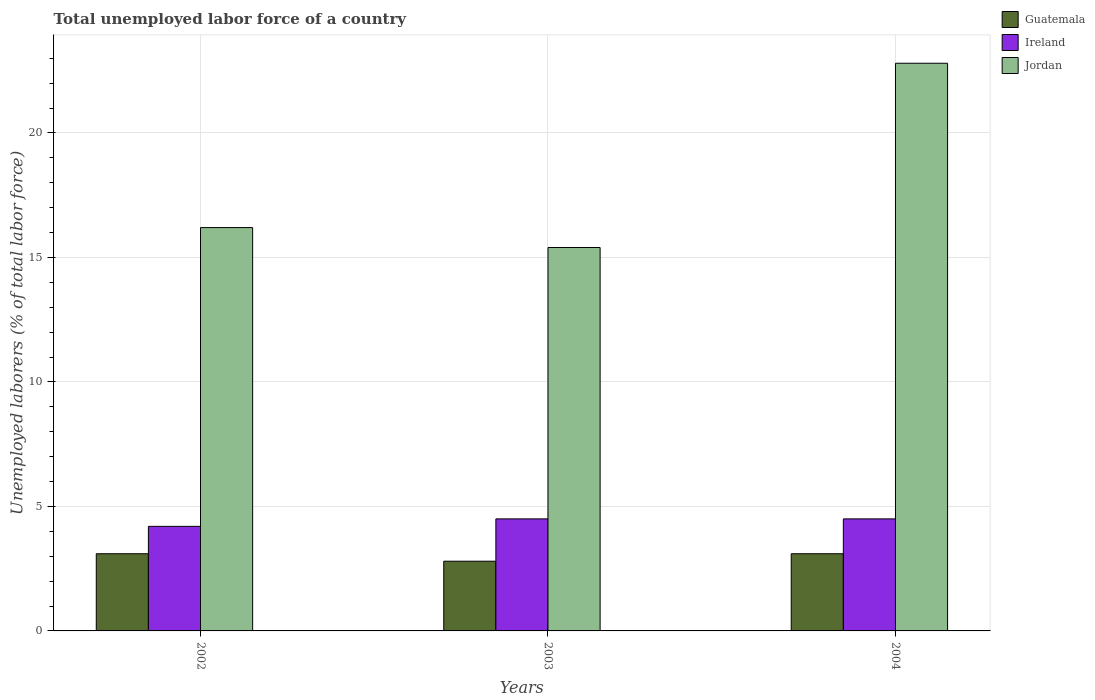How many groups of bars are there?
Your answer should be very brief. 3. Are the number of bars on each tick of the X-axis equal?
Provide a succinct answer. Yes. How many bars are there on the 1st tick from the right?
Keep it short and to the point. 3. What is the label of the 2nd group of bars from the left?
Provide a succinct answer. 2003. What is the total unemployed labor force in Jordan in 2003?
Provide a succinct answer. 15.4. Across all years, what is the minimum total unemployed labor force in Guatemala?
Offer a very short reply. 2.8. In which year was the total unemployed labor force in Guatemala minimum?
Your response must be concise. 2003. What is the total total unemployed labor force in Guatemala in the graph?
Ensure brevity in your answer.  9. What is the difference between the total unemployed labor force in Ireland in 2002 and that in 2003?
Offer a very short reply. -0.3. What is the difference between the total unemployed labor force in Ireland in 2003 and the total unemployed labor force in Guatemala in 2002?
Your answer should be very brief. 1.4. What is the average total unemployed labor force in Jordan per year?
Make the answer very short. 18.13. In the year 2002, what is the difference between the total unemployed labor force in Jordan and total unemployed labor force in Guatemala?
Your response must be concise. 13.1. In how many years, is the total unemployed labor force in Guatemala greater than 13 %?
Your answer should be very brief. 0. Is the total unemployed labor force in Guatemala in 2002 less than that in 2004?
Your answer should be very brief. No. What is the difference between the highest and the lowest total unemployed labor force in Ireland?
Ensure brevity in your answer.  0.3. In how many years, is the total unemployed labor force in Ireland greater than the average total unemployed labor force in Ireland taken over all years?
Provide a succinct answer. 2. What does the 1st bar from the left in 2002 represents?
Offer a very short reply. Guatemala. What does the 2nd bar from the right in 2003 represents?
Keep it short and to the point. Ireland. How many bars are there?
Offer a very short reply. 9. Are all the bars in the graph horizontal?
Provide a succinct answer. No. Does the graph contain any zero values?
Your response must be concise. No. Does the graph contain grids?
Your answer should be compact. Yes. Where does the legend appear in the graph?
Your response must be concise. Top right. What is the title of the graph?
Ensure brevity in your answer.  Total unemployed labor force of a country. What is the label or title of the X-axis?
Your answer should be very brief. Years. What is the label or title of the Y-axis?
Your response must be concise. Unemployed laborers (% of total labor force). What is the Unemployed laborers (% of total labor force) of Guatemala in 2002?
Make the answer very short. 3.1. What is the Unemployed laborers (% of total labor force) in Ireland in 2002?
Offer a terse response. 4.2. What is the Unemployed laborers (% of total labor force) in Jordan in 2002?
Provide a short and direct response. 16.2. What is the Unemployed laborers (% of total labor force) in Guatemala in 2003?
Your answer should be compact. 2.8. What is the Unemployed laborers (% of total labor force) in Ireland in 2003?
Provide a short and direct response. 4.5. What is the Unemployed laborers (% of total labor force) in Jordan in 2003?
Offer a terse response. 15.4. What is the Unemployed laborers (% of total labor force) in Guatemala in 2004?
Keep it short and to the point. 3.1. What is the Unemployed laborers (% of total labor force) of Ireland in 2004?
Your answer should be very brief. 4.5. What is the Unemployed laborers (% of total labor force) of Jordan in 2004?
Make the answer very short. 22.8. Across all years, what is the maximum Unemployed laborers (% of total labor force) of Guatemala?
Ensure brevity in your answer.  3.1. Across all years, what is the maximum Unemployed laborers (% of total labor force) in Jordan?
Offer a terse response. 22.8. Across all years, what is the minimum Unemployed laborers (% of total labor force) of Guatemala?
Your response must be concise. 2.8. Across all years, what is the minimum Unemployed laborers (% of total labor force) in Ireland?
Your answer should be very brief. 4.2. Across all years, what is the minimum Unemployed laborers (% of total labor force) of Jordan?
Provide a succinct answer. 15.4. What is the total Unemployed laborers (% of total labor force) of Ireland in the graph?
Offer a terse response. 13.2. What is the total Unemployed laborers (% of total labor force) of Jordan in the graph?
Keep it short and to the point. 54.4. What is the difference between the Unemployed laborers (% of total labor force) in Guatemala in 2002 and that in 2003?
Your answer should be very brief. 0.3. What is the difference between the Unemployed laborers (% of total labor force) of Jordan in 2002 and that in 2003?
Offer a terse response. 0.8. What is the difference between the Unemployed laborers (% of total labor force) of Guatemala in 2002 and that in 2004?
Your answer should be very brief. 0. What is the difference between the Unemployed laborers (% of total labor force) of Guatemala in 2002 and the Unemployed laborers (% of total labor force) of Ireland in 2003?
Make the answer very short. -1.4. What is the difference between the Unemployed laborers (% of total labor force) in Guatemala in 2002 and the Unemployed laborers (% of total labor force) in Jordan in 2003?
Ensure brevity in your answer.  -12.3. What is the difference between the Unemployed laborers (% of total labor force) in Guatemala in 2002 and the Unemployed laborers (% of total labor force) in Jordan in 2004?
Your answer should be very brief. -19.7. What is the difference between the Unemployed laborers (% of total labor force) in Ireland in 2002 and the Unemployed laborers (% of total labor force) in Jordan in 2004?
Offer a terse response. -18.6. What is the difference between the Unemployed laborers (% of total labor force) in Guatemala in 2003 and the Unemployed laborers (% of total labor force) in Jordan in 2004?
Your response must be concise. -20. What is the difference between the Unemployed laborers (% of total labor force) in Ireland in 2003 and the Unemployed laborers (% of total labor force) in Jordan in 2004?
Provide a succinct answer. -18.3. What is the average Unemployed laborers (% of total labor force) in Ireland per year?
Keep it short and to the point. 4.4. What is the average Unemployed laborers (% of total labor force) in Jordan per year?
Ensure brevity in your answer.  18.13. In the year 2002, what is the difference between the Unemployed laborers (% of total labor force) in Guatemala and Unemployed laborers (% of total labor force) in Jordan?
Provide a succinct answer. -13.1. In the year 2003, what is the difference between the Unemployed laborers (% of total labor force) in Guatemala and Unemployed laborers (% of total labor force) in Jordan?
Ensure brevity in your answer.  -12.6. In the year 2004, what is the difference between the Unemployed laborers (% of total labor force) of Guatemala and Unemployed laborers (% of total labor force) of Jordan?
Offer a terse response. -19.7. In the year 2004, what is the difference between the Unemployed laborers (% of total labor force) in Ireland and Unemployed laborers (% of total labor force) in Jordan?
Your answer should be compact. -18.3. What is the ratio of the Unemployed laborers (% of total labor force) in Guatemala in 2002 to that in 2003?
Provide a succinct answer. 1.11. What is the ratio of the Unemployed laborers (% of total labor force) of Jordan in 2002 to that in 2003?
Offer a terse response. 1.05. What is the ratio of the Unemployed laborers (% of total labor force) in Guatemala in 2002 to that in 2004?
Provide a succinct answer. 1. What is the ratio of the Unemployed laborers (% of total labor force) of Jordan in 2002 to that in 2004?
Offer a very short reply. 0.71. What is the ratio of the Unemployed laborers (% of total labor force) in Guatemala in 2003 to that in 2004?
Provide a succinct answer. 0.9. What is the ratio of the Unemployed laborers (% of total labor force) in Ireland in 2003 to that in 2004?
Your answer should be compact. 1. What is the ratio of the Unemployed laborers (% of total labor force) of Jordan in 2003 to that in 2004?
Give a very brief answer. 0.68. What is the difference between the highest and the second highest Unemployed laborers (% of total labor force) in Guatemala?
Your response must be concise. 0. What is the difference between the highest and the second highest Unemployed laborers (% of total labor force) of Ireland?
Provide a succinct answer. 0. What is the difference between the highest and the lowest Unemployed laborers (% of total labor force) in Ireland?
Offer a very short reply. 0.3. 